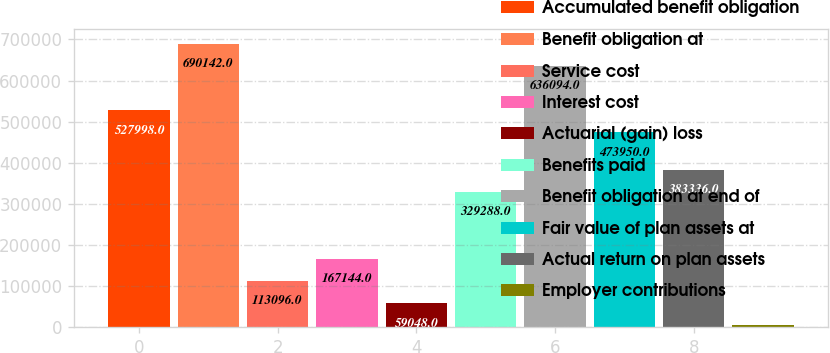Convert chart. <chart><loc_0><loc_0><loc_500><loc_500><bar_chart><fcel>Accumulated benefit obligation<fcel>Benefit obligation at<fcel>Service cost<fcel>Interest cost<fcel>Actuarial (gain) loss<fcel>Benefits paid<fcel>Benefit obligation at end of<fcel>Fair value of plan assets at<fcel>Actual return on plan assets<fcel>Employer contributions<nl><fcel>527998<fcel>690142<fcel>113096<fcel>167144<fcel>59048<fcel>329288<fcel>636094<fcel>473950<fcel>383336<fcel>5000<nl></chart> 